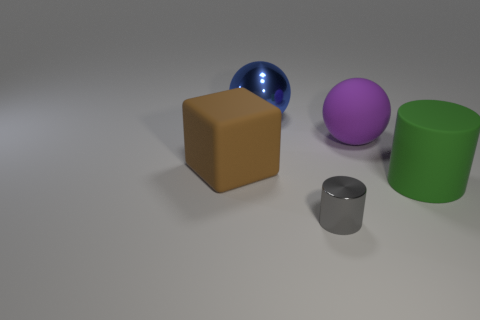Add 3 matte spheres. How many objects exist? 8 Subtract all cylinders. How many objects are left? 3 Subtract 0 purple blocks. How many objects are left? 5 Subtract all tiny red metallic cubes. Subtract all green rubber cylinders. How many objects are left? 4 Add 4 big purple things. How many big purple things are left? 5 Add 1 small rubber things. How many small rubber things exist? 1 